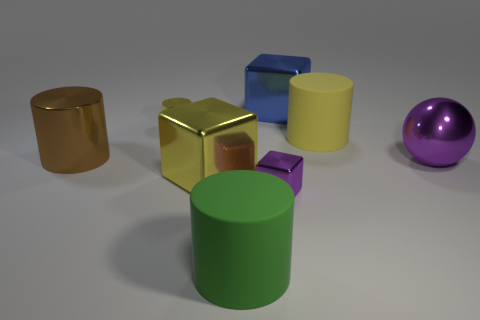Are there any tiny cubes?
Your answer should be very brief. Yes. Are there fewer large blue metal cubes left of the yellow shiny block than large purple objects in front of the small shiny cube?
Make the answer very short. No. What shape is the large metal object behind the big brown cylinder?
Your answer should be compact. Cube. Do the large yellow cube and the tiny yellow cylinder have the same material?
Provide a succinct answer. Yes. Are there any other things that have the same material as the large blue thing?
Your answer should be very brief. Yes. There is a purple object that is the same shape as the blue metal object; what is its material?
Ensure brevity in your answer.  Metal. Is the number of large metallic blocks behind the tiny yellow cylinder less than the number of purple shiny spheres?
Keep it short and to the point. No. How many tiny yellow metal cylinders are to the left of the yellow shiny cylinder?
Offer a very short reply. 0. Is the shape of the yellow metallic thing that is in front of the brown metallic cylinder the same as the small metallic thing that is in front of the big yellow cylinder?
Keep it short and to the point. Yes. There is a thing that is both behind the big purple metal thing and right of the blue cube; what shape is it?
Ensure brevity in your answer.  Cylinder. 